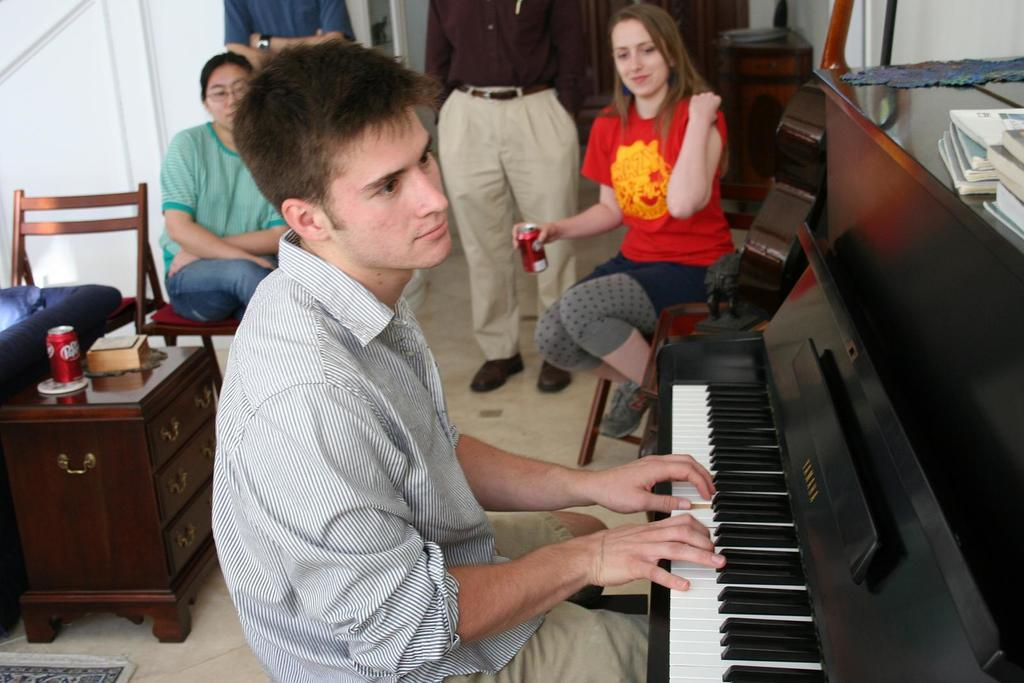How many people are in the image? There are people in the image, but the exact number is not specified. What are the people in the image doing? Some people are sitting, while others are standing. What object related to music can be seen in the image? There is a musical instrument in the image. What type of furniture is present in the image? There is a cupboard in the image. What is placed on the cupboard? There is a can on the cupboard. What type of pain is being expressed by the people in the image? There is no indication of pain or any emotional state in the image; the people are simply sitting or standing. What type of wool is being used to create the musical instrument in the image? The musical instrument in the image does not appear to be made of wool, and there is no mention of wool in the facts provided. 